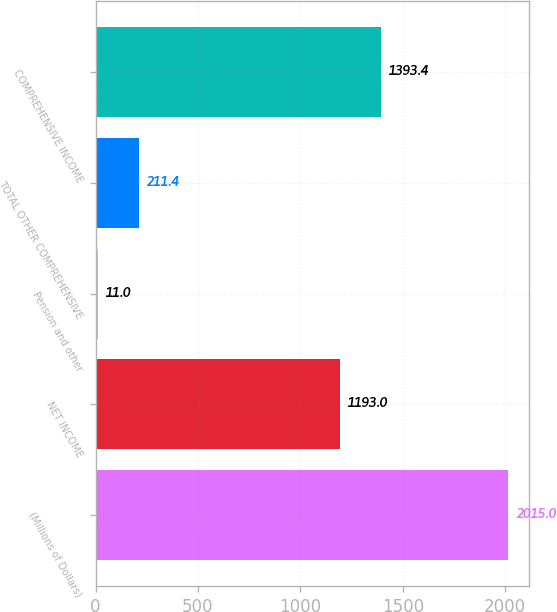Convert chart to OTSL. <chart><loc_0><loc_0><loc_500><loc_500><bar_chart><fcel>(Millions of Dollars)<fcel>NET INCOME<fcel>Pension and other<fcel>TOTAL OTHER COMPREHENSIVE<fcel>COMPREHENSIVE INCOME<nl><fcel>2015<fcel>1193<fcel>11<fcel>211.4<fcel>1393.4<nl></chart> 